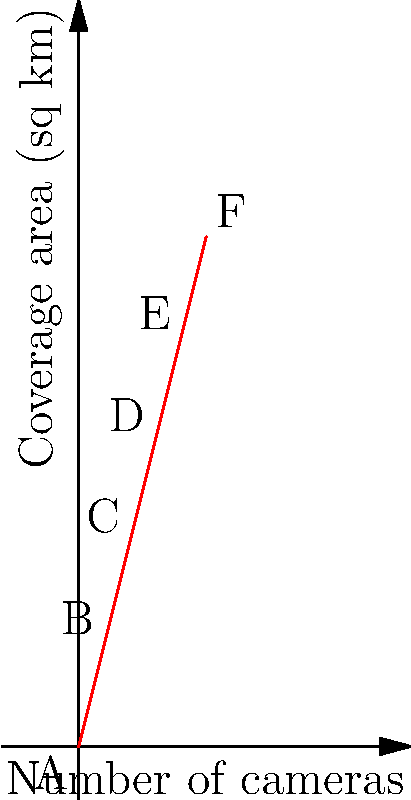The graph shows the relationship between the number of facial recognition cameras installed in a city and the total area covered by their surveillance. If the city plans to cover an area of 14 square kilometers, how many cameras would be required based on this relationship? To solve this problem, we need to analyze the graph and interpolate between the given data points:

1. Observe that the relationship between the number of cameras and the coverage area is linear.
2. The data points are:
   A (0, 0), B (1, 4), C (2, 8), D (3, 12), E (4, 16), F (5, 20)
3. We need to find the number of cameras for a coverage area of 14 sq km.
4. 14 sq km falls between points D (3, 12) and E (4, 16).
5. Calculate the slope of the line:
   Slope = $\frac{\text{Change in y}}{\text{Change in x}} = \frac{4}{1} = 4$
6. Use the point-slope form of a line equation:
   $y - y_1 = m(x - x_1)$
   Where $(x_1, y_1)$ is a known point (e.g., D (3, 12)), $m$ is the slope, and $(x, y)$ is our target point.
7. Substitute the values:
   $14 - 12 = 4(x - 3)$
8. Solve for $x$:
   $2 = 4(x - 3)$
   $\frac{1}{2} = x - 3$
   $x = 3.5$

Therefore, 3.5 cameras would be required to cover 14 sq km.
Answer: 3.5 cameras 